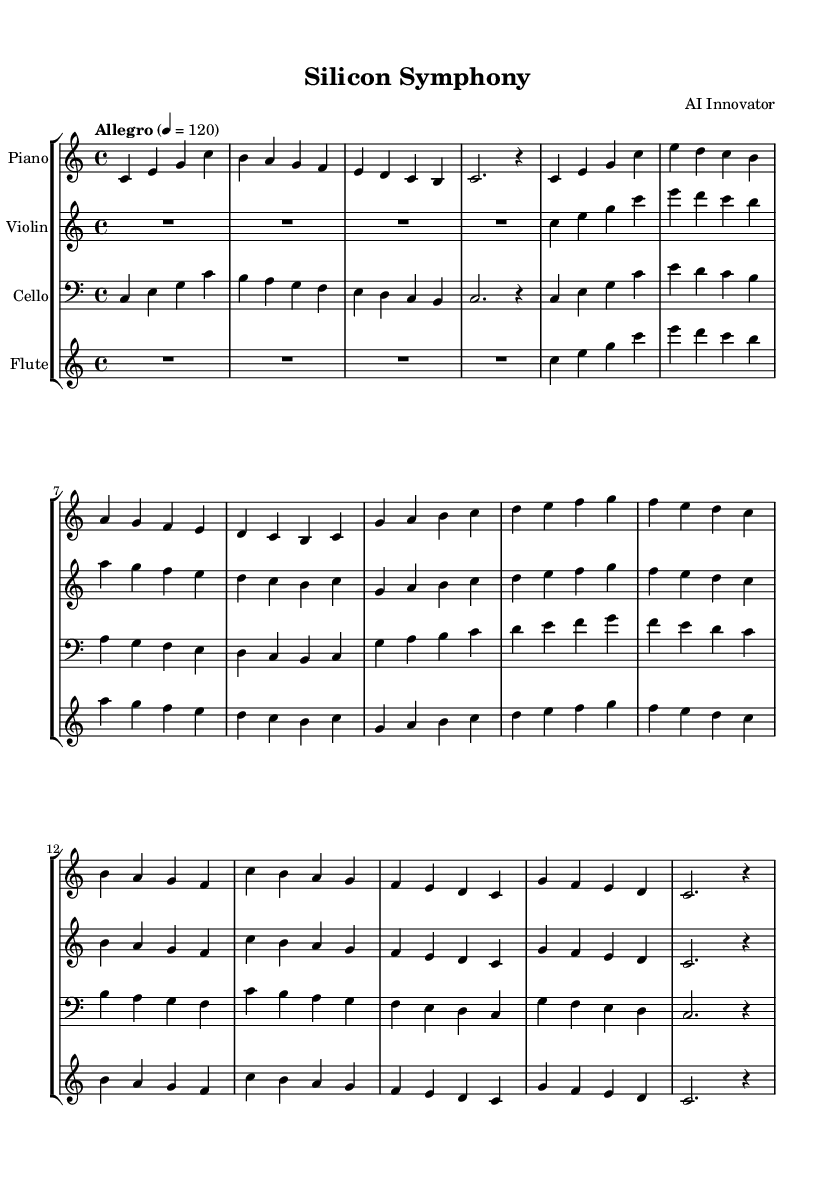What is the key signature of this music? The key signature is indicated at the beginning of the score. It is C major, which has no sharps or flats noted in the music.
Answer: C major What is the time signature of this composition? The time signature appears at the beginning of the score, indicating the number of beats in each measure. Here it shows four beats per measure (4/4).
Answer: 4/4 What is the tempo marking for this piece? The tempo marking is specified above the staff, indicating how fast the piece should be played. In this case, it is marked as "Allegro" with a metronome marking of 120 beats per minute.
Answer: Allegro Which instrument plays the theme first? By examining the score, the piano part introduces the themes initially, as it is first in the staff group. The first staff showcases the piano notes.
Answer: Piano How many measures are in the introduction section? The introduction section consists of four measures, as counted from the beginning of the piano part.
Answer: 4 What is the range of the flute part in this composition? The flute part starts in the middle octave and ranges up to the higher octave notes. By looking at the notes played, it covers notes from C in the second octave to C in the third octave.
Answer: C to C Which thematic material is repeated in the music? The answer is found by identifying patterns in the score. Themes A and B, represented by distinct melodic phrases, are repeated throughout the composition, particularly in the piano and violin parts.
Answer: Theme A and Theme B 